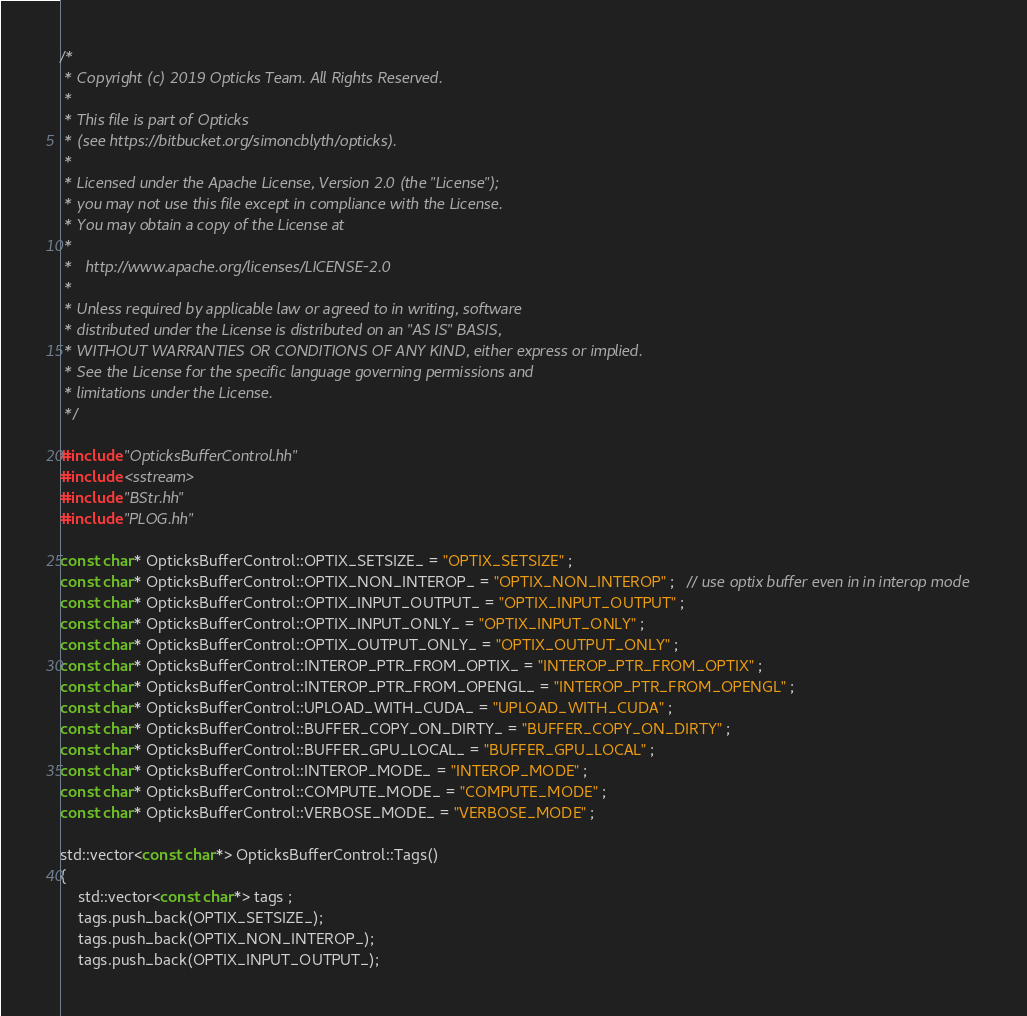<code> <loc_0><loc_0><loc_500><loc_500><_C++_>/*
 * Copyright (c) 2019 Opticks Team. All Rights Reserved.
 *
 * This file is part of Opticks
 * (see https://bitbucket.org/simoncblyth/opticks).
 *
 * Licensed under the Apache License, Version 2.0 (the "License"); 
 * you may not use this file except in compliance with the License.  
 * You may obtain a copy of the License at
 *
 *   http://www.apache.org/licenses/LICENSE-2.0
 *
 * Unless required by applicable law or agreed to in writing, software 
 * distributed under the License is distributed on an "AS IS" BASIS, 
 * WITHOUT WARRANTIES OR CONDITIONS OF ANY KIND, either express or implied.  
 * See the License for the specific language governing permissions and 
 * limitations under the License.
 */

#include "OpticksBufferControl.hh"
#include <sstream>
#include "BStr.hh"
#include "PLOG.hh"

const char* OpticksBufferControl::OPTIX_SETSIZE_ = "OPTIX_SETSIZE" ; 
const char* OpticksBufferControl::OPTIX_NON_INTEROP_ = "OPTIX_NON_INTEROP" ;   // use optix buffer even in in interop mode
const char* OpticksBufferControl::OPTIX_INPUT_OUTPUT_ = "OPTIX_INPUT_OUTPUT" ; 
const char* OpticksBufferControl::OPTIX_INPUT_ONLY_ = "OPTIX_INPUT_ONLY" ; 
const char* OpticksBufferControl::OPTIX_OUTPUT_ONLY_ = "OPTIX_OUTPUT_ONLY" ; 
const char* OpticksBufferControl::INTEROP_PTR_FROM_OPTIX_ = "INTEROP_PTR_FROM_OPTIX" ; 
const char* OpticksBufferControl::INTEROP_PTR_FROM_OPENGL_ = "INTEROP_PTR_FROM_OPENGL" ; 
const char* OpticksBufferControl::UPLOAD_WITH_CUDA_ = "UPLOAD_WITH_CUDA" ; 
const char* OpticksBufferControl::BUFFER_COPY_ON_DIRTY_ = "BUFFER_COPY_ON_DIRTY" ; 
const char* OpticksBufferControl::BUFFER_GPU_LOCAL_ = "BUFFER_GPU_LOCAL" ; 
const char* OpticksBufferControl::INTEROP_MODE_ = "INTEROP_MODE" ; 
const char* OpticksBufferControl::COMPUTE_MODE_ = "COMPUTE_MODE" ; 
const char* OpticksBufferControl::VERBOSE_MODE_ = "VERBOSE_MODE" ; 

std::vector<const char*> OpticksBufferControl::Tags()
{
    std::vector<const char*> tags ; 
    tags.push_back(OPTIX_SETSIZE_);
    tags.push_back(OPTIX_NON_INTEROP_);
    tags.push_back(OPTIX_INPUT_OUTPUT_);</code> 